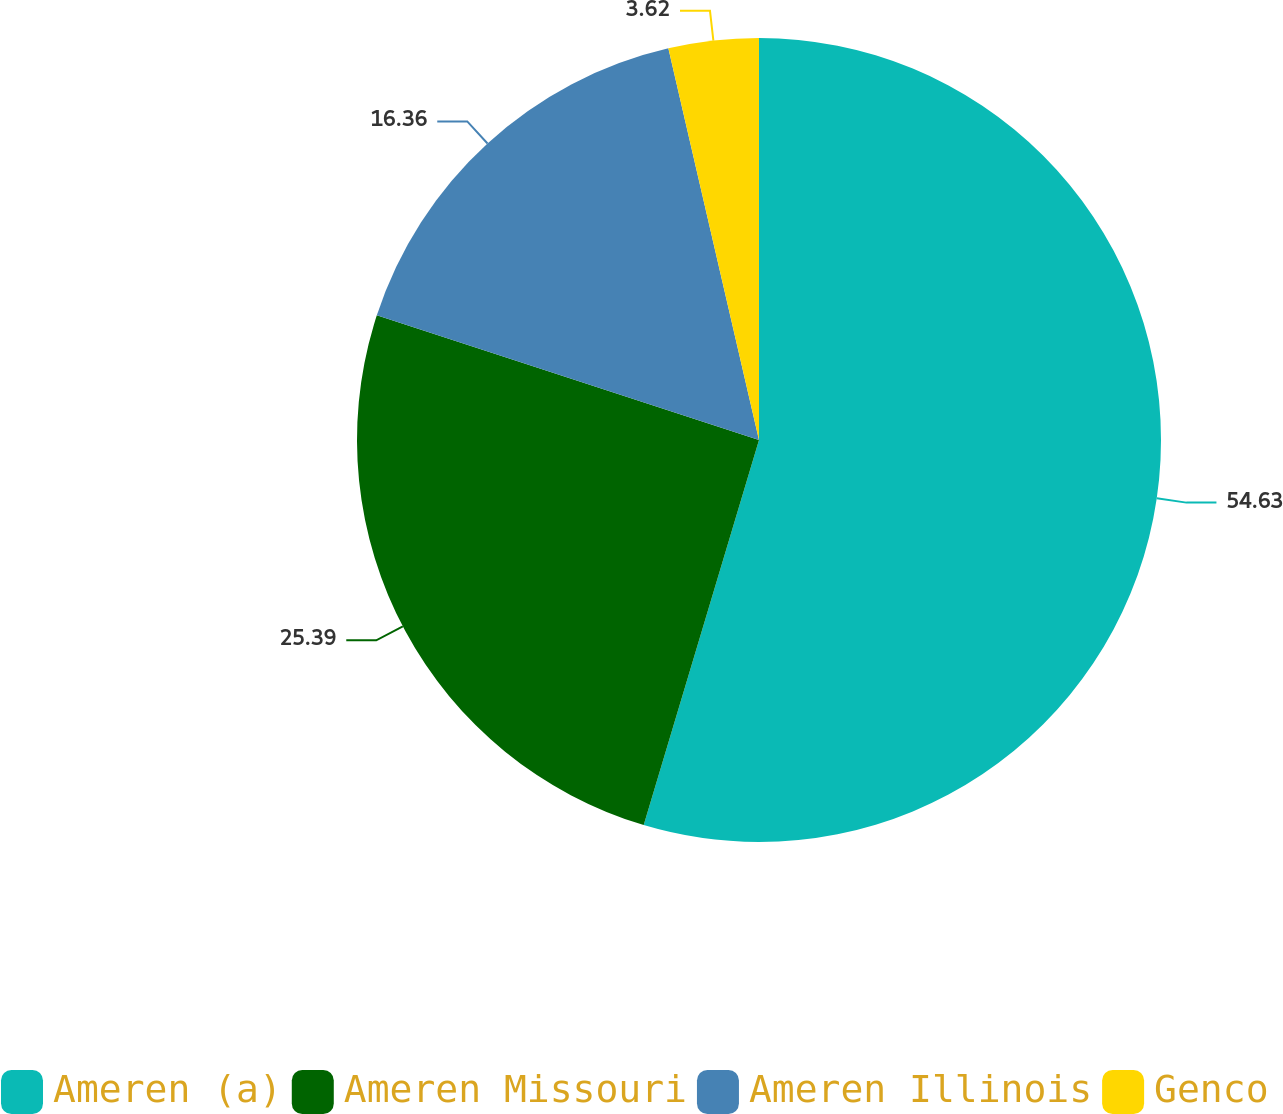<chart> <loc_0><loc_0><loc_500><loc_500><pie_chart><fcel>Ameren (a)<fcel>Ameren Missouri<fcel>Ameren Illinois<fcel>Genco<nl><fcel>54.63%<fcel>25.39%<fcel>16.36%<fcel>3.62%<nl></chart> 